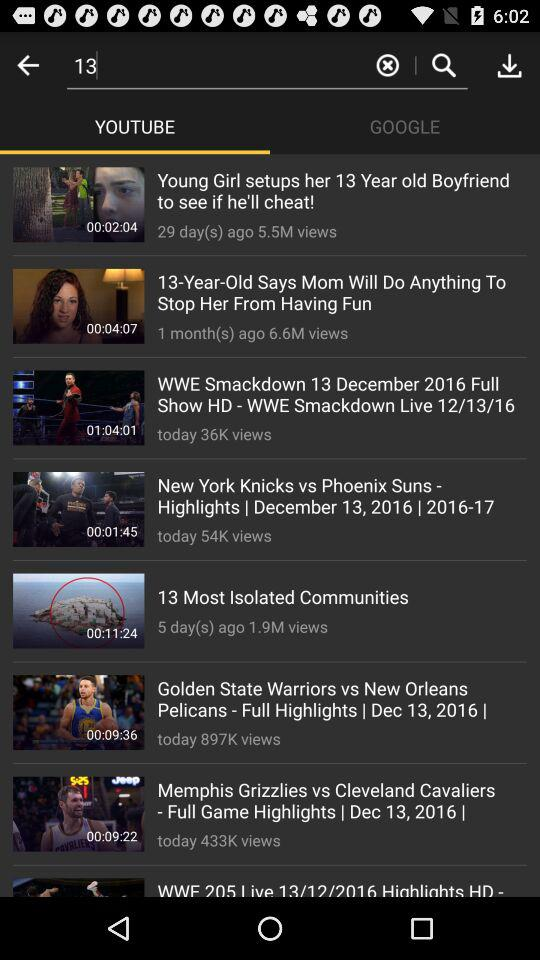Which is the selected tab? The selected tab is "YOUTUBE". 